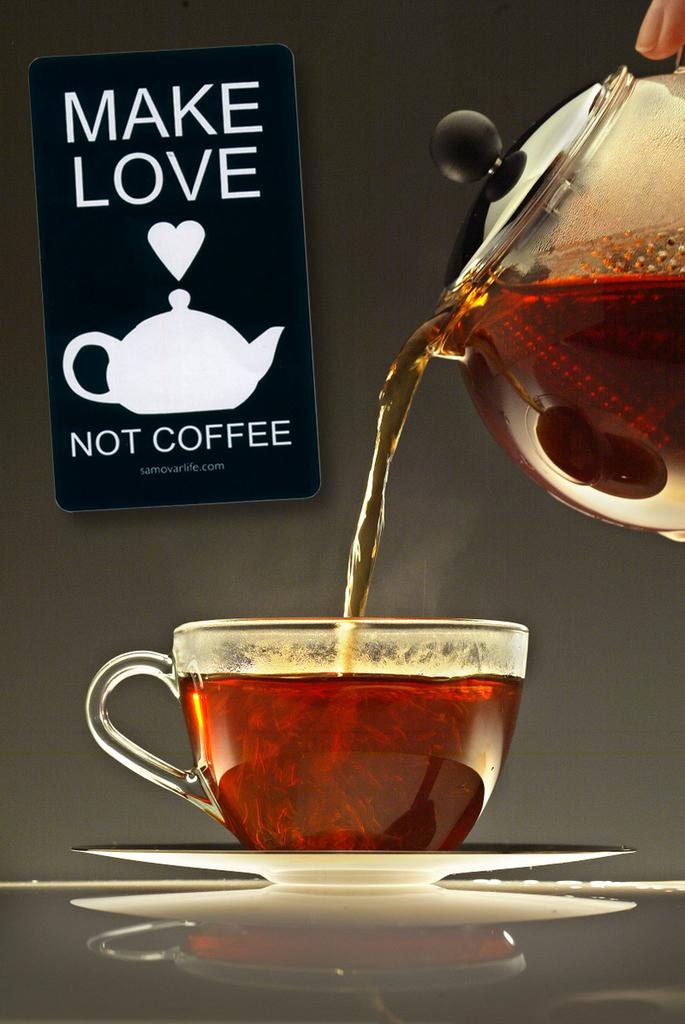What is located in the center of the image? There is a coffee cup and a jar in the center of the image. What is inside the coffee cup? There is coffee in the center of the image. What can be seen in the background of the image? There is a wall and a banner in the background of the image. How many friends are visible in the image? There are no friends visible in the image; it only features a coffee cup, a jar, coffee, a wall, and a banner. 